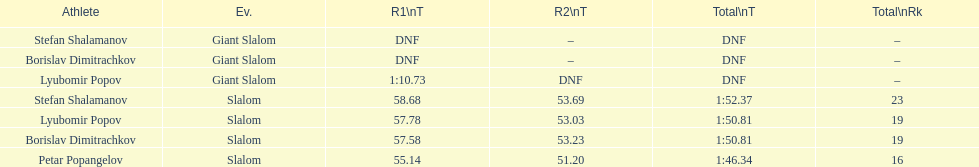Could you parse the entire table as a dict? {'header': ['Athlete', 'Ev.', 'R1\\nT', 'R2\\nT', 'Total\\nT', 'Total\\nRk'], 'rows': [['Stefan Shalamanov', 'Giant Slalom', 'DNF', '–', 'DNF', '–'], ['Borislav Dimitrachkov', 'Giant Slalom', 'DNF', '–', 'DNF', '–'], ['Lyubomir Popov', 'Giant Slalom', '1:10.73', 'DNF', 'DNF', '–'], ['Stefan Shalamanov', 'Slalom', '58.68', '53.69', '1:52.37', '23'], ['Lyubomir Popov', 'Slalom', '57.78', '53.03', '1:50.81', '19'], ['Borislav Dimitrachkov', 'Slalom', '57.58', '53.23', '1:50.81', '19'], ['Petar Popangelov', 'Slalom', '55.14', '51.20', '1:46.34', '16']]} Who came after borislav dimitrachkov and it's time for slalom Petar Popangelov. 